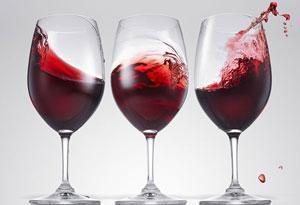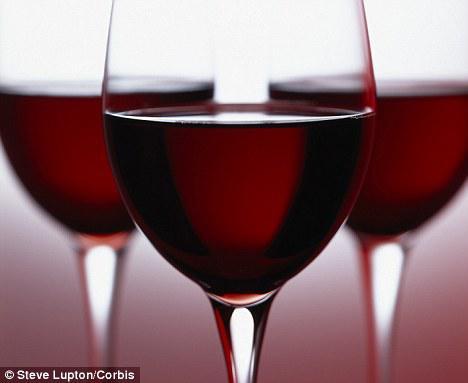The first image is the image on the left, the second image is the image on the right. For the images shown, is this caption "An image shows red wine splashing up the side of at least one stemmed glass." true? Answer yes or no. Yes. The first image is the image on the left, the second image is the image on the right. Given the left and right images, does the statement "At least one glass of wine is active and swirling around the wine glass." hold true? Answer yes or no. Yes. 